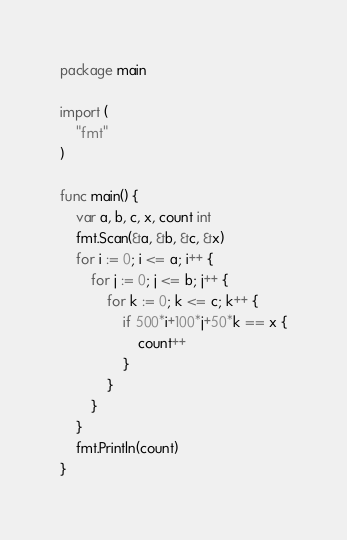Convert code to text. <code><loc_0><loc_0><loc_500><loc_500><_Go_>package main

import (
	"fmt"
)

func main() {
	var a, b, c, x, count int
	fmt.Scan(&a, &b, &c, &x)
	for i := 0; i <= a; i++ {
		for j := 0; j <= b; j++ {
			for k := 0; k <= c; k++ {
				if 500*i+100*j+50*k == x {
					count++
				}
			}
		}
	}
	fmt.Println(count)
}
</code> 